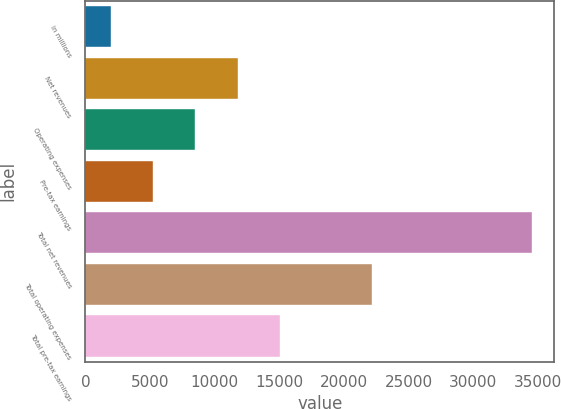Convert chart to OTSL. <chart><loc_0><loc_0><loc_500><loc_500><bar_chart><fcel>in millions<fcel>Net revenues<fcel>Operating expenses<fcel>Pre-tax earnings<fcel>Total net revenues<fcel>Total operating expenses<fcel>Total pre-tax earnings<nl><fcel>2014<fcel>11768.2<fcel>8516.8<fcel>5265.4<fcel>34528<fcel>22171<fcel>15019.6<nl></chart> 